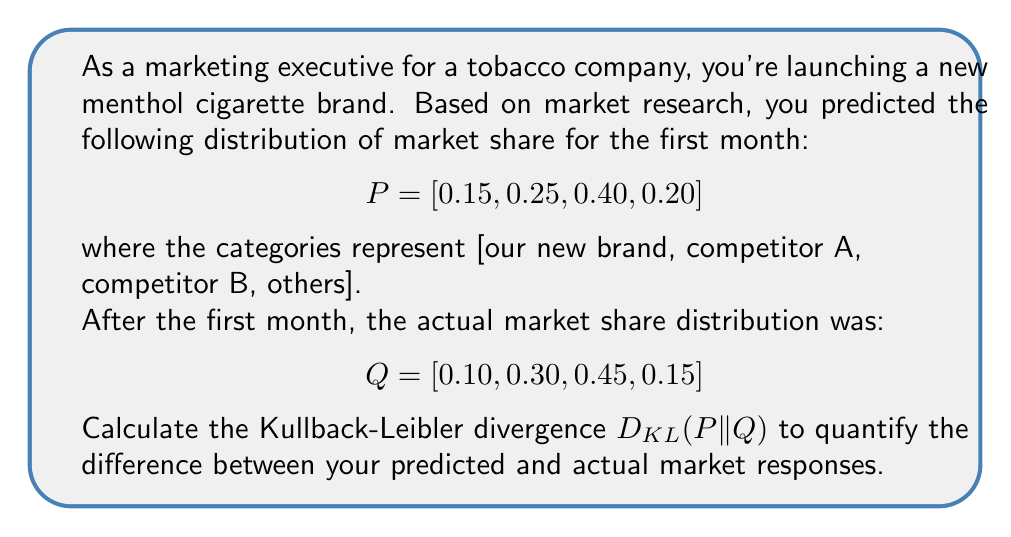Can you answer this question? To solve this problem, we'll use the Kullback-Leibler divergence formula:

$$D_{KL}(P||Q) = \sum_{i} P(i) \log\left(\frac{P(i)}{Q(i)}\right)$$

Let's calculate each term:

1) For i = 1 (our new brand):
   $P(1) \log\left(\frac{P(1)}{Q(1)}\right) = 0.15 \log\left(\frac{0.15}{0.10}\right) = 0.15 \log(1.5) = 0.0608$

2) For i = 2 (competitor A):
   $P(2) \log\left(\frac{P(2)}{Q(2)}\right) = 0.25 \log\left(\frac{0.25}{0.30}\right) = 0.25 \log(0.8333) = -0.0451$

3) For i = 3 (competitor B):
   $P(3) \log\left(\frac{P(3)}{Q(3)}\right) = 0.40 \log\left(\frac{0.40}{0.45}\right) = 0.40 \log(0.8889) = -0.0471$

4) For i = 4 (others):
   $P(4) \log\left(\frac{P(4)}{Q(4)}\right) = 0.20 \log\left(\frac{0.20}{0.15}\right) = 0.20 \log(1.3333) = 0.0575$

Now, we sum all these terms:

$D_{KL}(P||Q) = 0.0608 + (-0.0451) + (-0.0471) + 0.0575 = 0.0261$

Therefore, the Kullback-Leibler divergence between the predicted and actual market responses is approximately 0.0261.
Answer: $D_{KL}(P||Q) \approx 0.0261$ 